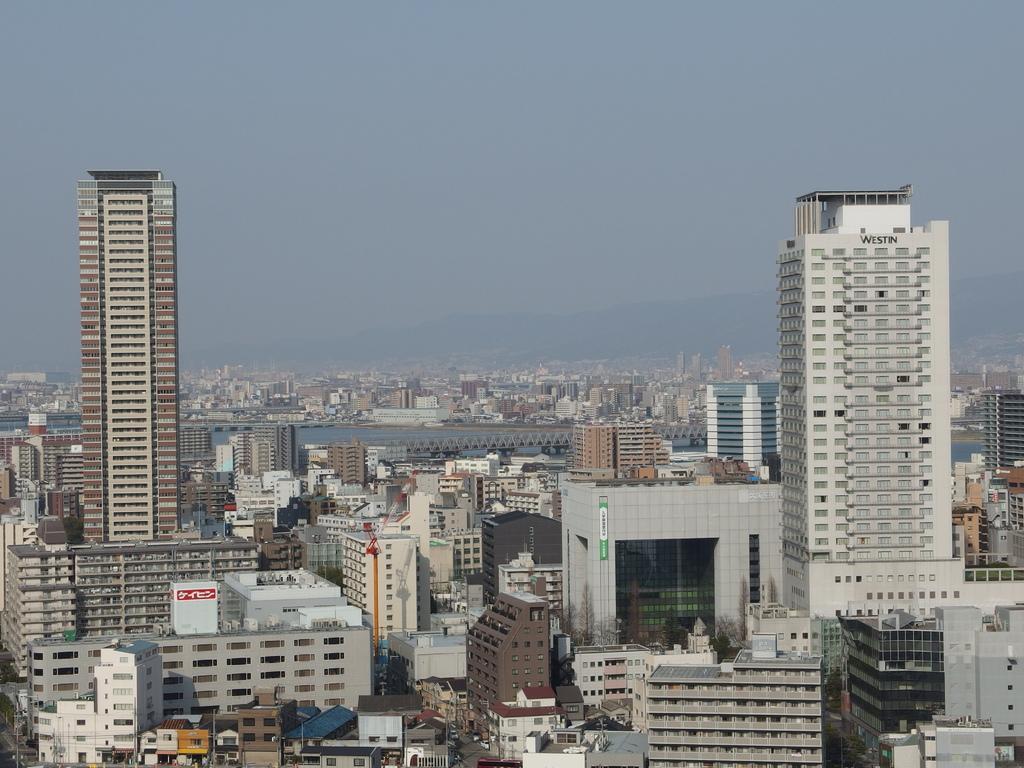Can you describe this image briefly? There are skyscrapers in the foreground area of the image and the sky in the background. 